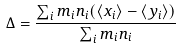Convert formula to latex. <formula><loc_0><loc_0><loc_500><loc_500>\Delta = \frac { \sum _ { i } m _ { i } n _ { i } ( \langle x _ { i } \rangle - \langle y _ { i } \rangle ) } { \sum _ { i } m _ { i } n _ { i } }</formula> 